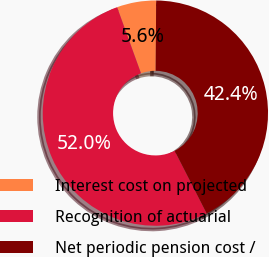Convert chart to OTSL. <chart><loc_0><loc_0><loc_500><loc_500><pie_chart><fcel>Interest cost on projected<fcel>Recognition of actuarial<fcel>Net periodic pension cost /<nl><fcel>5.63%<fcel>52.0%<fcel>42.37%<nl></chart> 